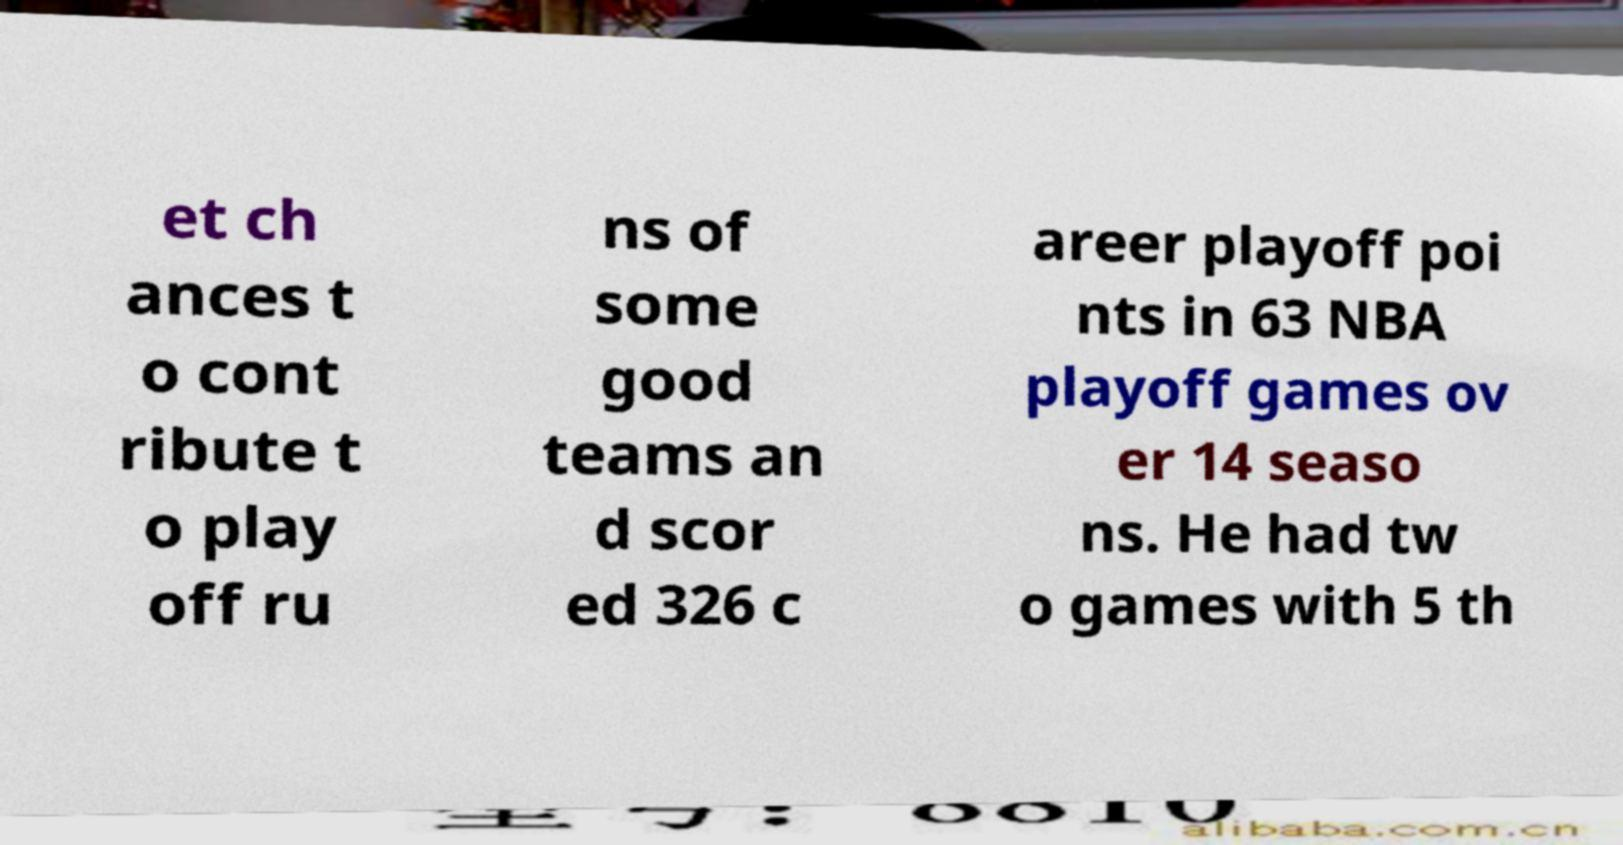Please identify and transcribe the text found in this image. et ch ances t o cont ribute t o play off ru ns of some good teams an d scor ed 326 c areer playoff poi nts in 63 NBA playoff games ov er 14 seaso ns. He had tw o games with 5 th 